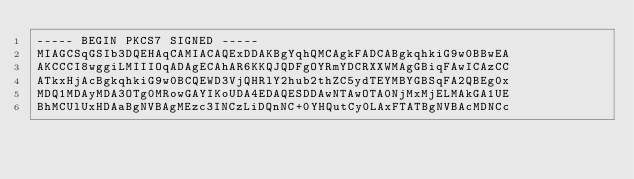Convert code to text. <code><loc_0><loc_0><loc_500><loc_500><_SML_>----- BEGIN PKCS7 SIGNED -----
MIAGCSqGSIb3DQEHAqCAMIACAQExDDAKBgYqhQMCAgkFADCABgkqhkiG9w0BBwEA
AKCCCI8wggiLMIIIOqADAgECAhAR6KKQJQDFgOYRmYDCRXXWMAgGBiqFAwICAzCC
ATkxHjAcBgkqhkiG9w0BCQEWD3VjQHRlY2hub2thZC5ydTEYMBYGBSqFA2QBEg0x
MDQ1MDAyMDA3OTg0MRowGAYIKoUDA4EDAQESDDAwNTAwOTA0NjMxMjELMAkGA1UE
BhMCUlUxHDAaBgNVBAgMEzc3INCzLiDQnNC+0YHQutCy0LAxFTATBgNVBAcMDNCc</code> 